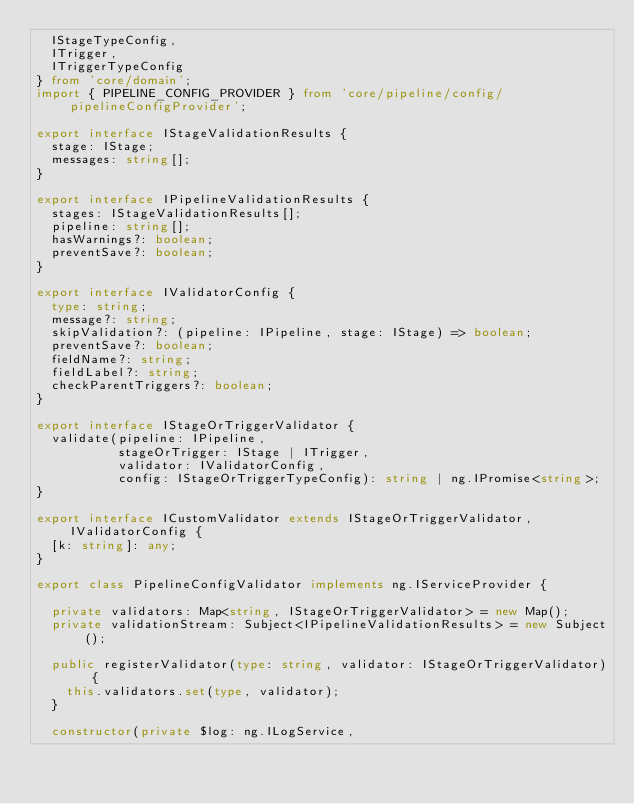Convert code to text. <code><loc_0><loc_0><loc_500><loc_500><_TypeScript_>  IStageTypeConfig,
  ITrigger,
  ITriggerTypeConfig
} from 'core/domain';
import { PIPELINE_CONFIG_PROVIDER } from 'core/pipeline/config/pipelineConfigProvider';

export interface IStageValidationResults {
  stage: IStage;
  messages: string[];
}

export interface IPipelineValidationResults {
  stages: IStageValidationResults[];
  pipeline: string[];
  hasWarnings?: boolean;
  preventSave?: boolean;
}

export interface IValidatorConfig {
  type: string;
  message?: string;
  skipValidation?: (pipeline: IPipeline, stage: IStage) => boolean;
  preventSave?: boolean;
  fieldName?: string;
  fieldLabel?: string;
  checkParentTriggers?: boolean;
}

export interface IStageOrTriggerValidator {
  validate(pipeline: IPipeline,
           stageOrTrigger: IStage | ITrigger,
           validator: IValidatorConfig,
           config: IStageOrTriggerTypeConfig): string | ng.IPromise<string>;
}

export interface ICustomValidator extends IStageOrTriggerValidator, IValidatorConfig {
  [k: string]: any;
}

export class PipelineConfigValidator implements ng.IServiceProvider {

  private validators: Map<string, IStageOrTriggerValidator> = new Map();
  private validationStream: Subject<IPipelineValidationResults> = new Subject();

  public registerValidator(type: string, validator: IStageOrTriggerValidator) {
    this.validators.set(type, validator);
  }

  constructor(private $log: ng.ILogService,</code> 